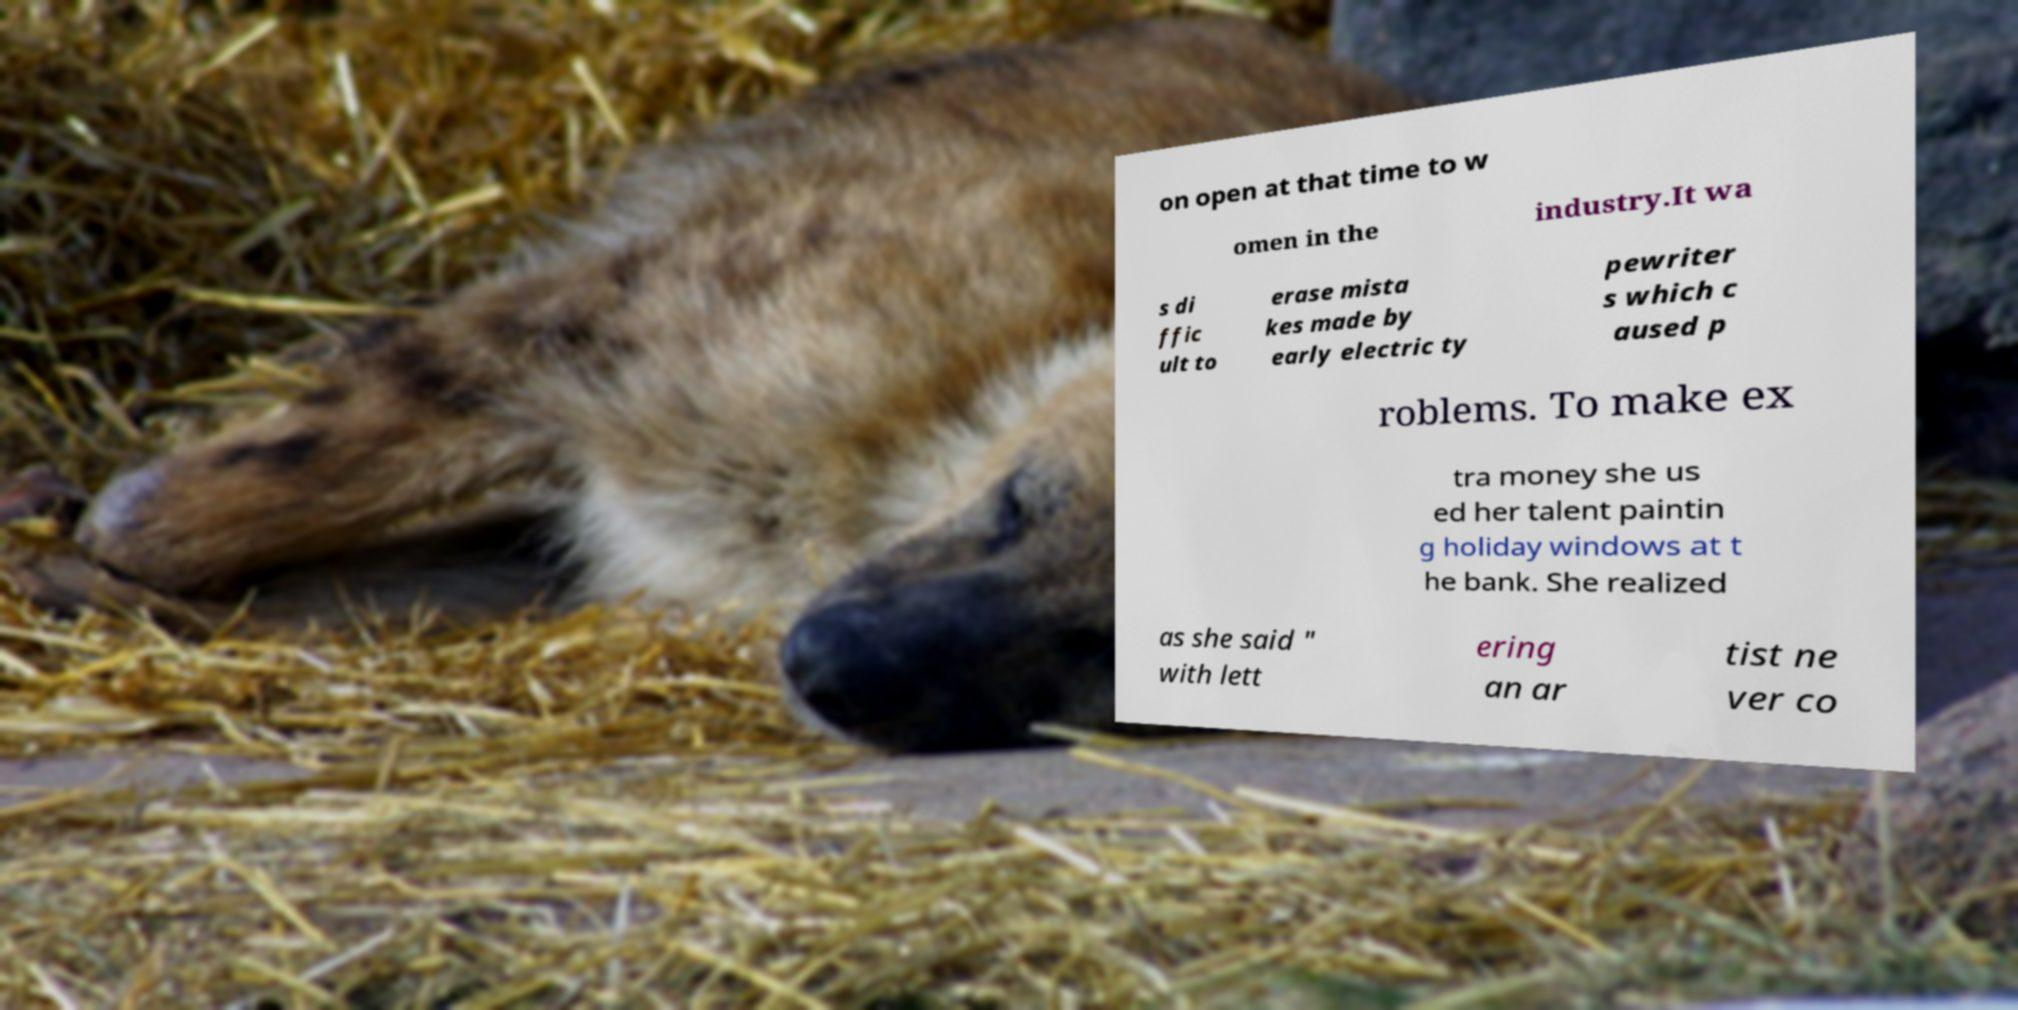Can you read and provide the text displayed in the image?This photo seems to have some interesting text. Can you extract and type it out for me? on open at that time to w omen in the industry.It wa s di ffic ult to erase mista kes made by early electric ty pewriter s which c aused p roblems. To make ex tra money she us ed her talent paintin g holiday windows at t he bank. She realized as she said " with lett ering an ar tist ne ver co 